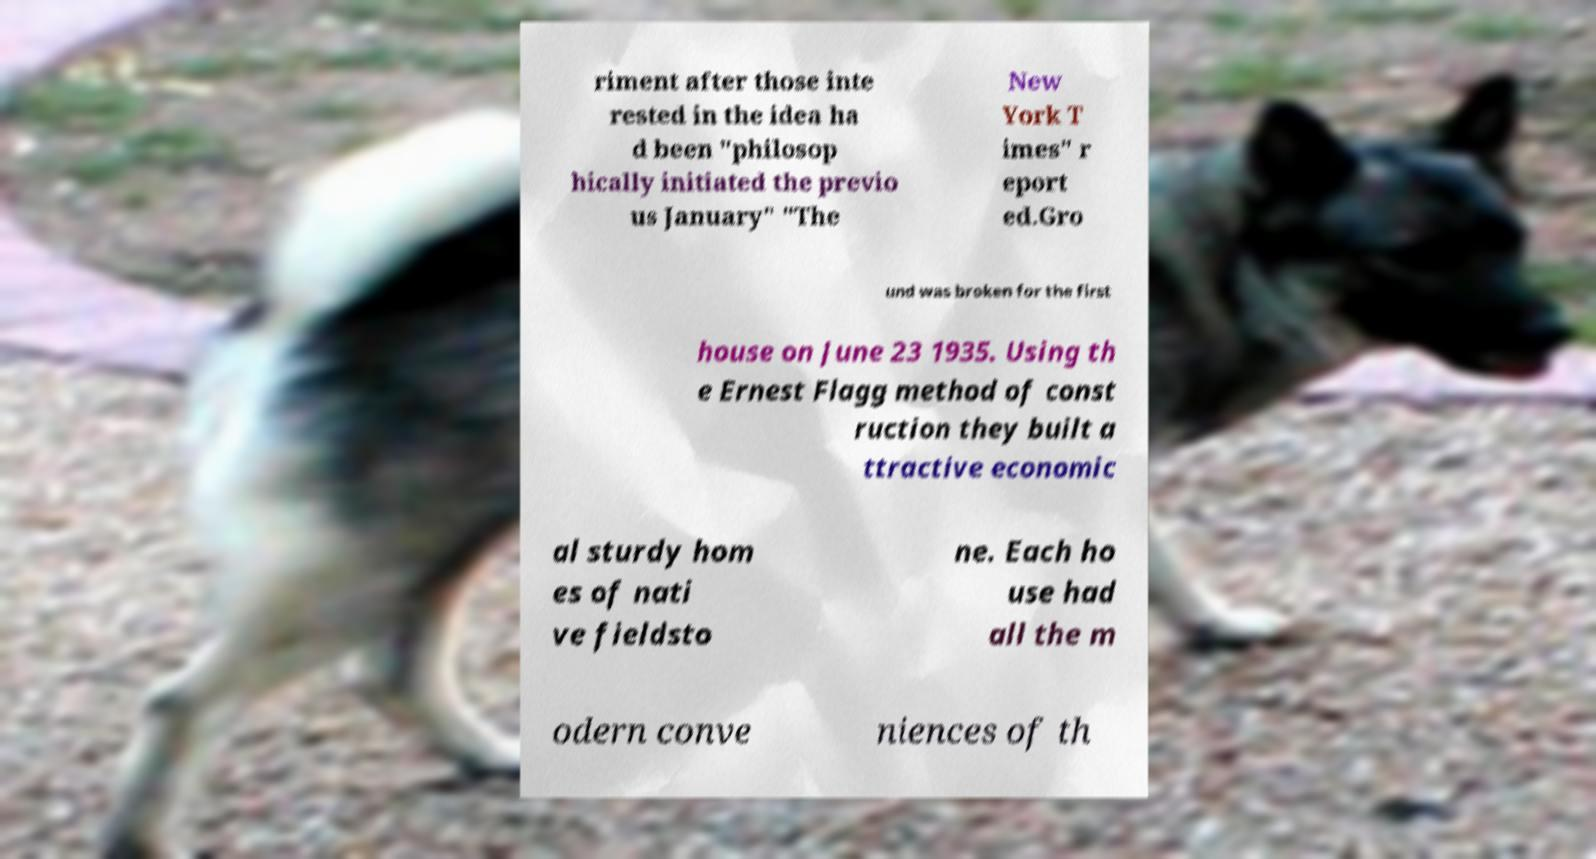Please identify and transcribe the text found in this image. riment after those inte rested in the idea ha d been "philosop hically initiated the previo us January" "The New York T imes" r eport ed.Gro und was broken for the first house on June 23 1935. Using th e Ernest Flagg method of const ruction they built a ttractive economic al sturdy hom es of nati ve fieldsto ne. Each ho use had all the m odern conve niences of th 